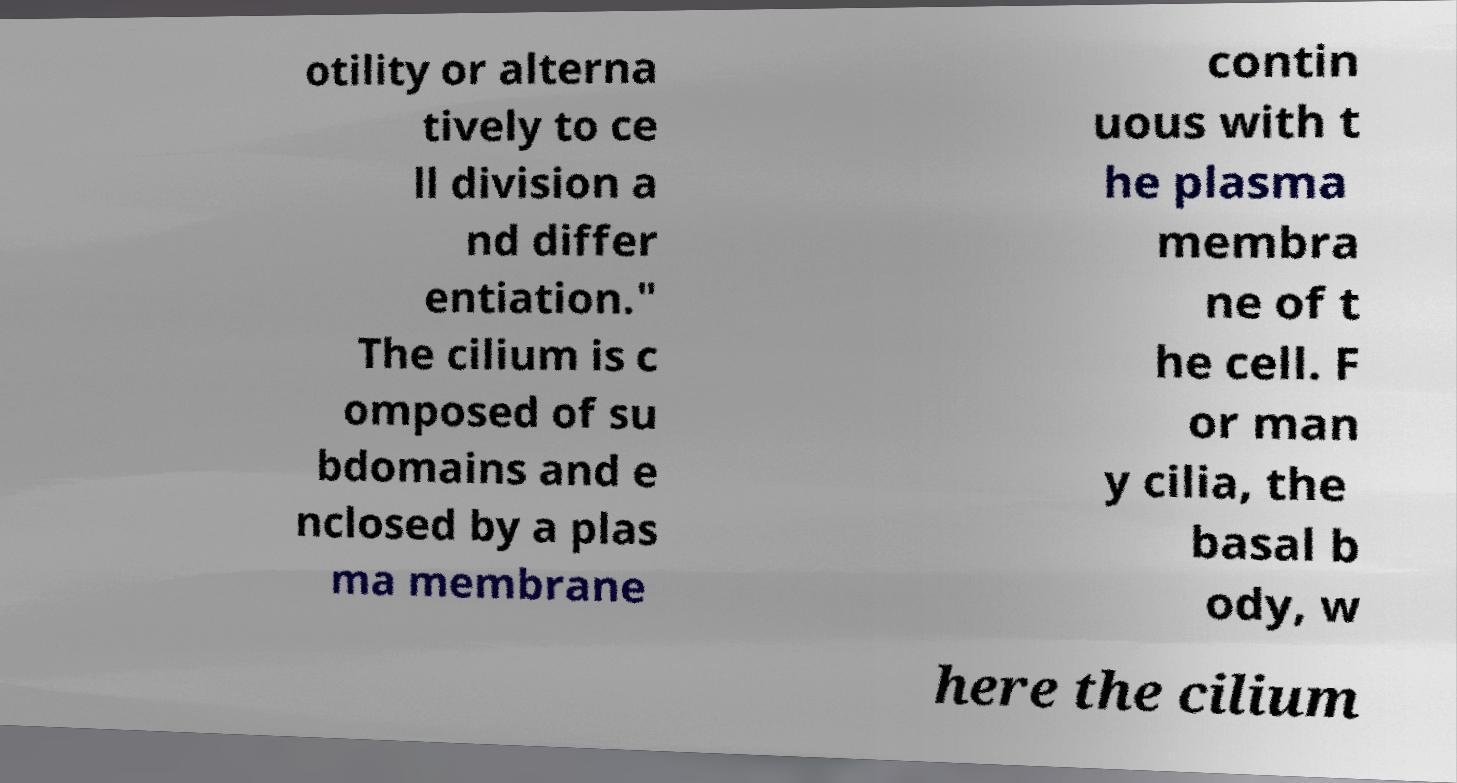I need the written content from this picture converted into text. Can you do that? otility or alterna tively to ce ll division a nd differ entiation." The cilium is c omposed of su bdomains and e nclosed by a plas ma membrane contin uous with t he plasma membra ne of t he cell. F or man y cilia, the basal b ody, w here the cilium 